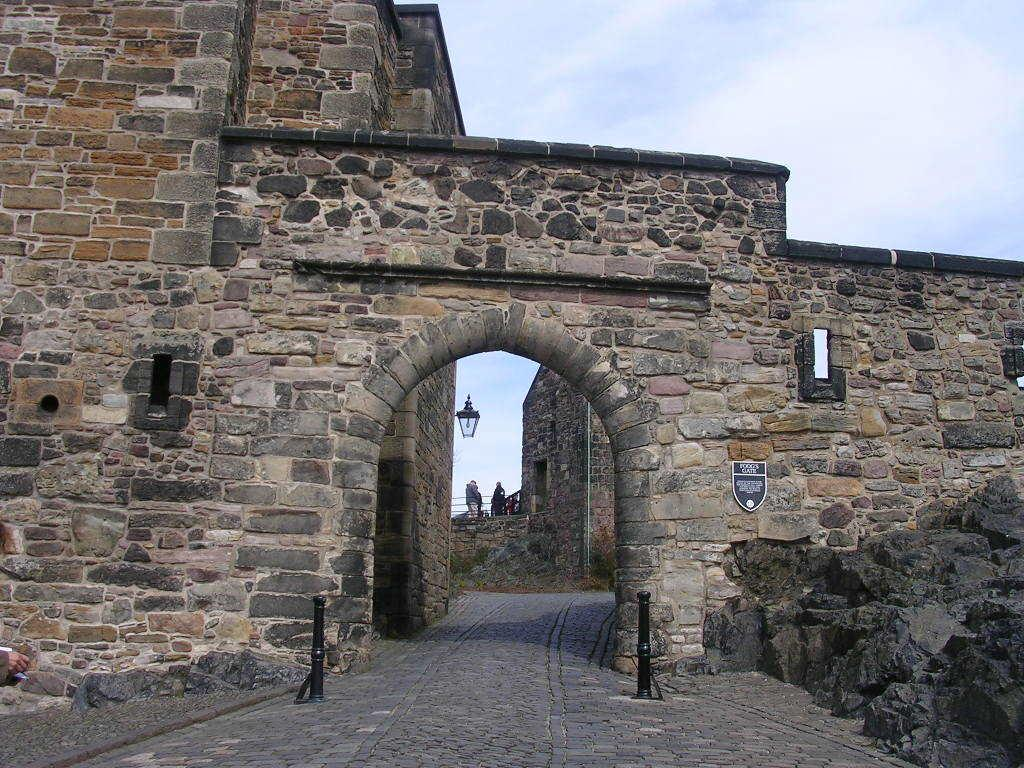What type of structure is depicted in the image? The image contains a castle made of stone walls. What objects can be seen in the foreground of the image? There are poles and a board in the foreground of the image. What is the central feature of the image? There is a light in the center of the image. How would you describe the weather in the image? The sky is cloudy in the image. What type of flowers are growing around the castle in the image? There are no flowers visible in the image; it only shows a castle, poles, a board, a light, and a cloudy sky. 